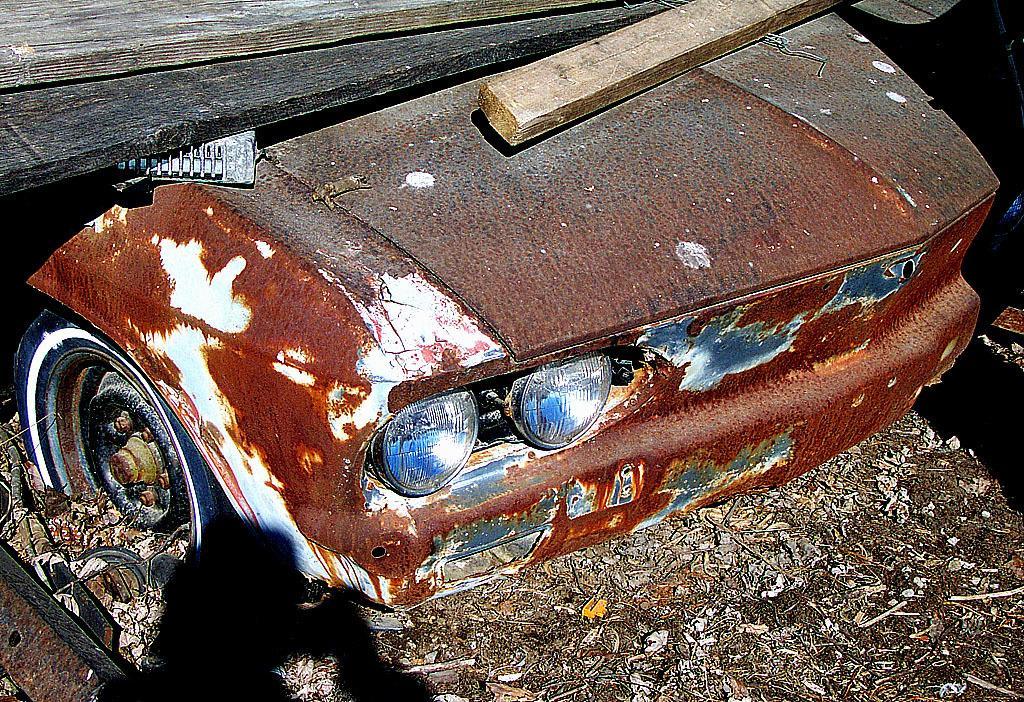Can you describe this image briefly? In this image we can see a old rusted car. On which there are wooden sticks. At the bottom of the image there is garbage. 